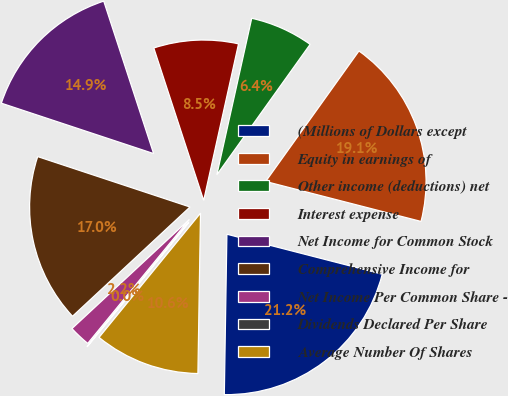<chart> <loc_0><loc_0><loc_500><loc_500><pie_chart><fcel>(Millions of Dollars except<fcel>Equity in earnings of<fcel>Other income (deductions) net<fcel>Interest expense<fcel>Net Income for Common Stock<fcel>Comprehensive Income for<fcel>Net Income Per Common Share -<fcel>Dividends Declared Per Share<fcel>Average Number Of Shares<nl><fcel>21.25%<fcel>19.13%<fcel>6.39%<fcel>8.52%<fcel>14.88%<fcel>17.01%<fcel>2.15%<fcel>0.03%<fcel>10.64%<nl></chart> 